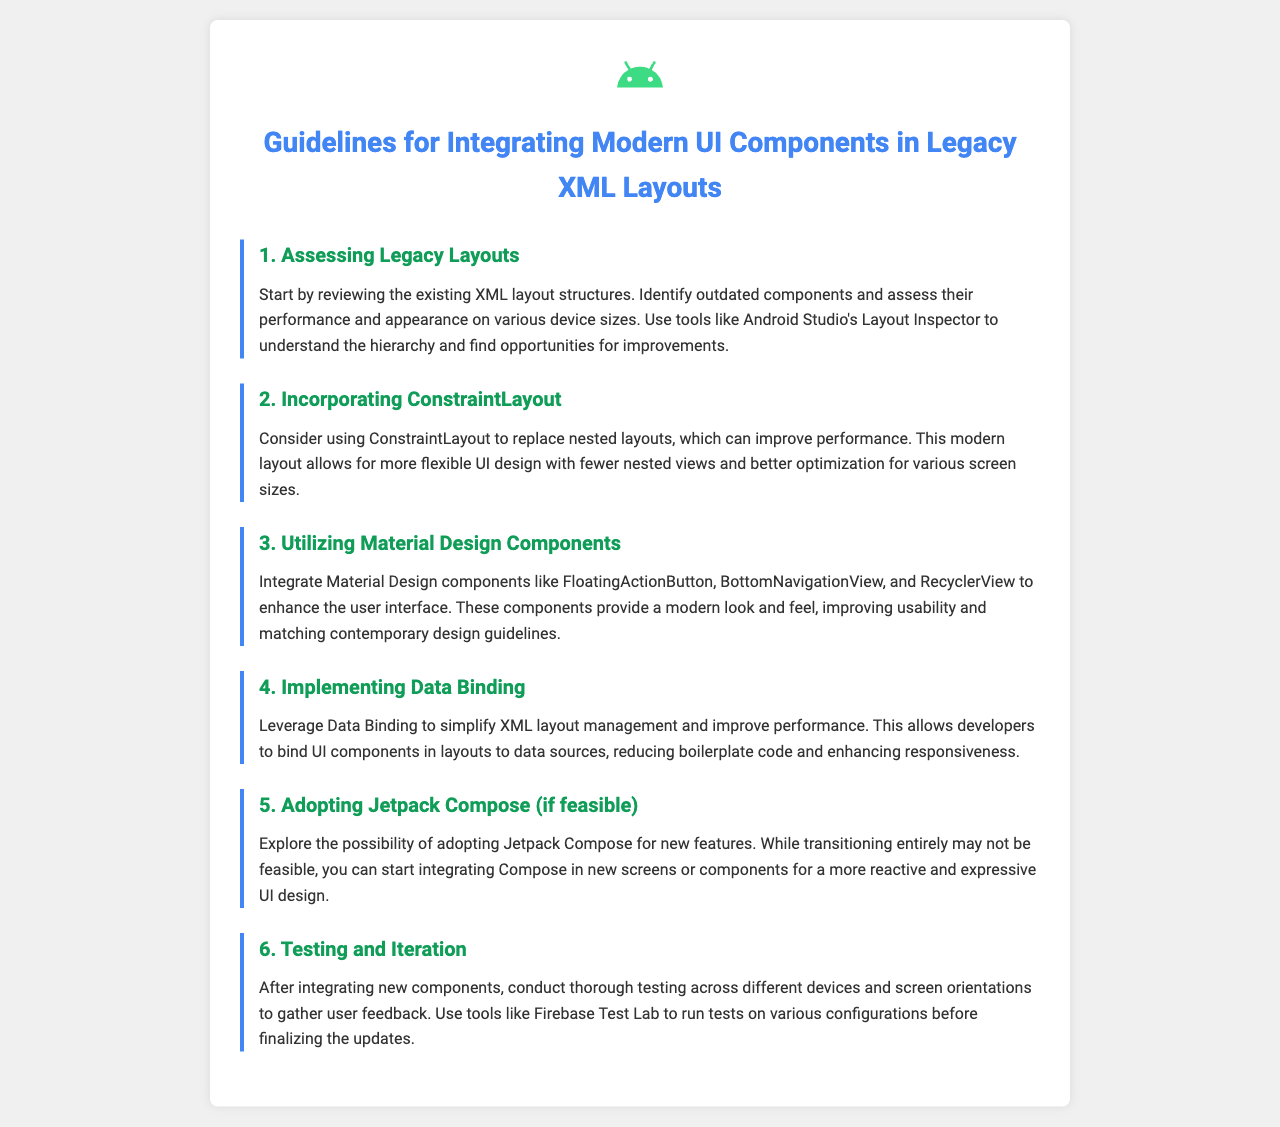What is the title of the document? The title of the document is provided in the <title> tag of the HTML.
Answer: Guidelines for Integrating Modern UI Components in Legacy XML Layouts How many guidelines are presented in the document? The guidelines are numbered from 1 to 6, indicating a total count.
Answer: 6 What layout is recommended to replace nested layouts? The document suggests a specific layout type that is known for flexibility and performance.
Answer: ConstraintLayout Which design components are suggested for integration? The document lists several specific components defined by modern design principles.
Answer: Material Design components What is recommended for testing after integrating new components? Testing is emphasized in a specific setting to ensure quality across variations.
Answer: Firebase Test Lab What should be used to bind UI components in layouts? The document refers to a specific feature that simplifies XML layout management.
Answer: Data Binding 